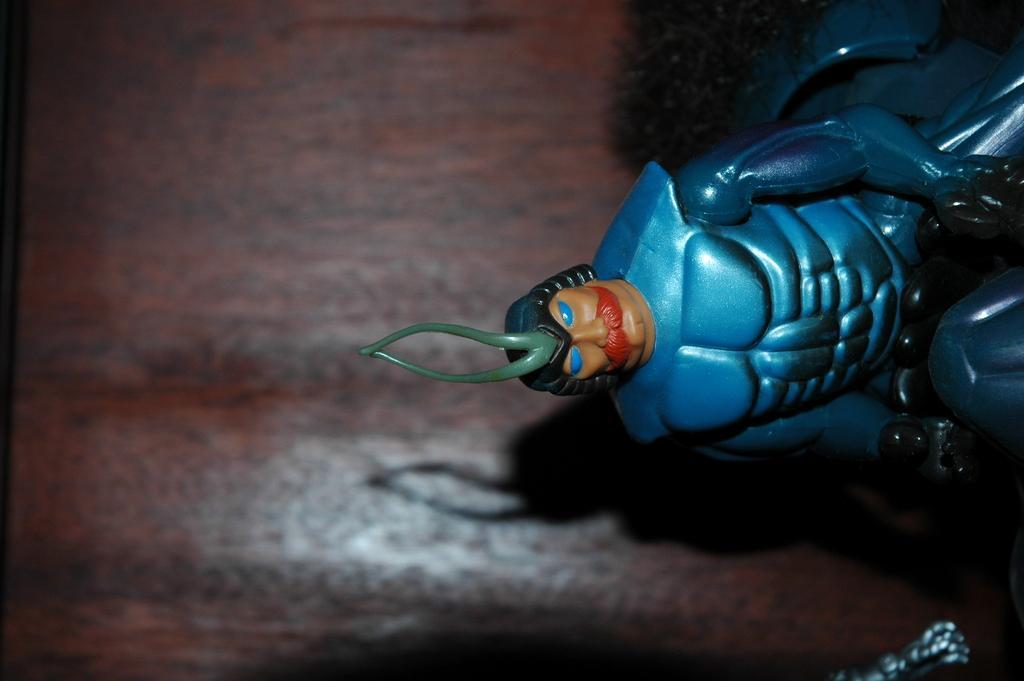Can you describe this image briefly? In this image we can see a blue color toy. The background of the image is blurred which is in brown color. 